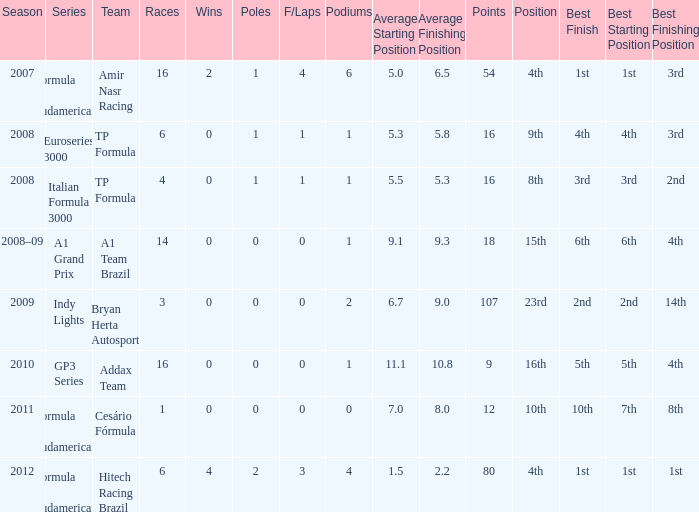0 poles? 80.0. 